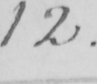Can you tell me what this handwritten text says? 12 . 